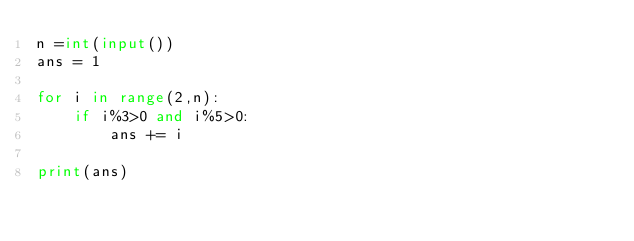Convert code to text. <code><loc_0><loc_0><loc_500><loc_500><_Python_>n =int(input())
ans = 1

for i in range(2,n):
    if i%3>0 and i%5>0:
        ans += i

print(ans)</code> 